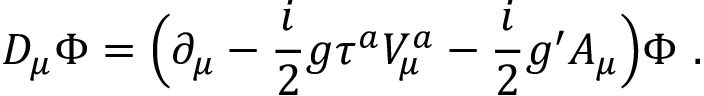<formula> <loc_0><loc_0><loc_500><loc_500>D _ { \mu } \Phi = \left ( \partial _ { \mu } - \frac { i } { 2 } g \tau ^ { a } V _ { \mu } ^ { a } - \frac { i } { 2 } g ^ { \prime } A _ { \mu } \right ) \Phi \ .</formula> 